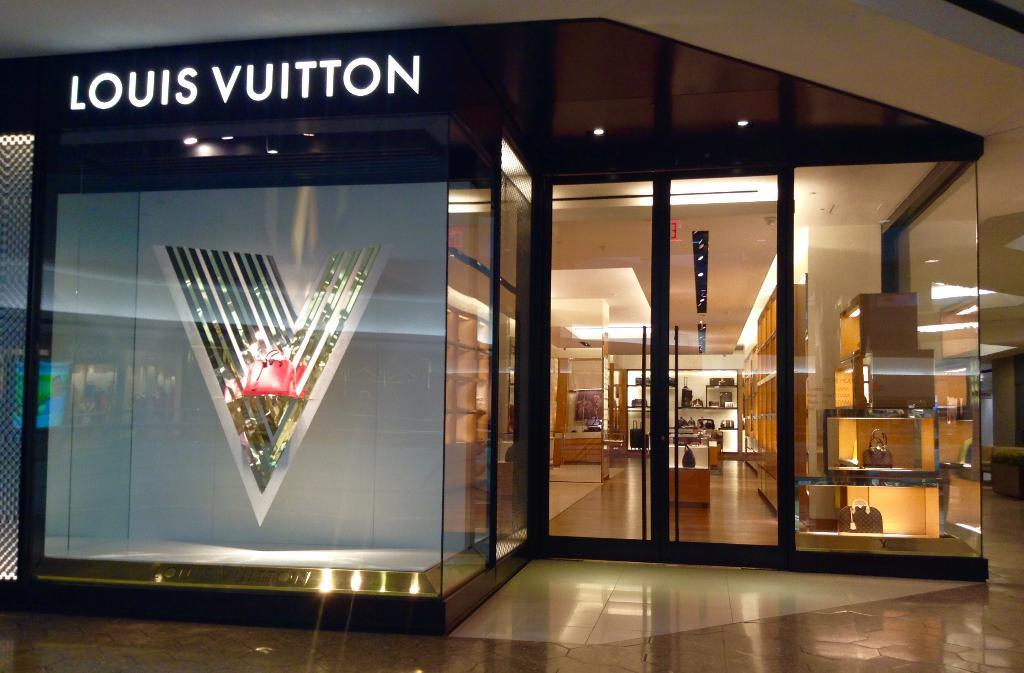<image>
Give a short and clear explanation of the subsequent image. a Louis Vuitton store that has items in it 